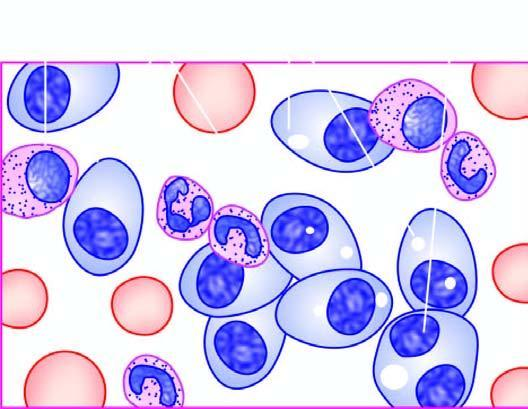what show numerous plasma cells, many with abnormal features?
Answer the question using a single word or phrase. Bone marrow aspirate 